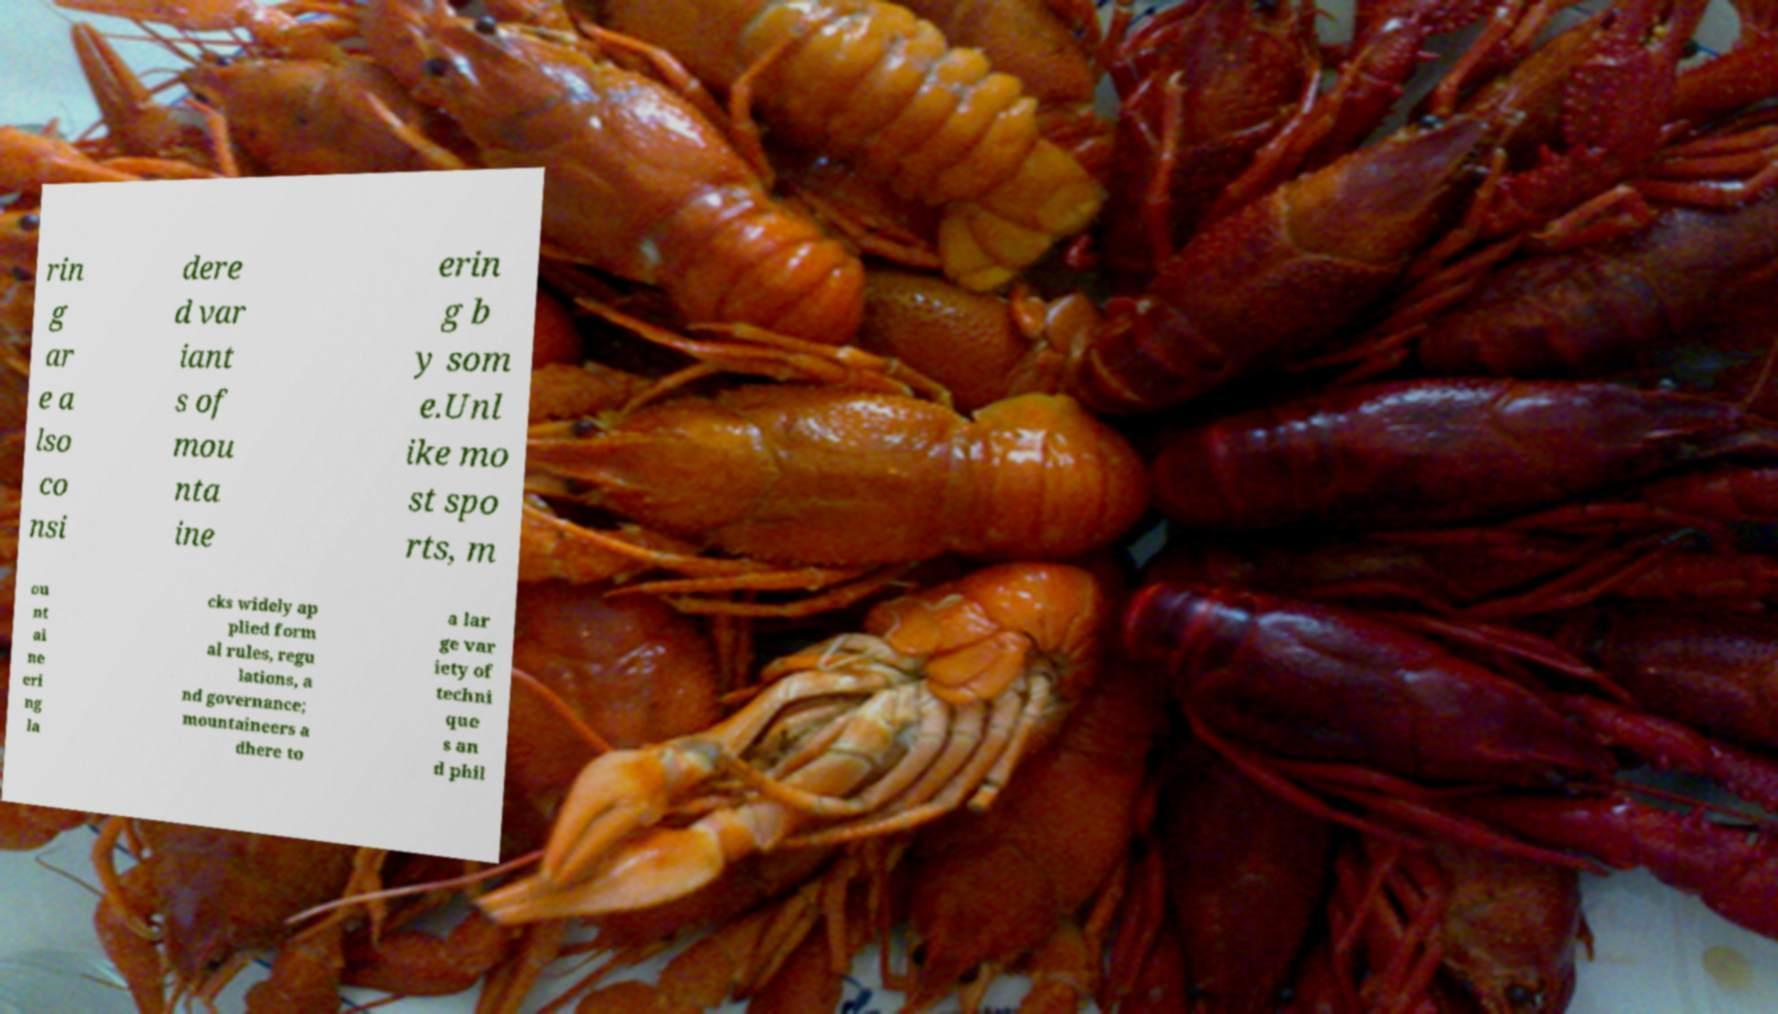For documentation purposes, I need the text within this image transcribed. Could you provide that? rin g ar e a lso co nsi dere d var iant s of mou nta ine erin g b y som e.Unl ike mo st spo rts, m ou nt ai ne eri ng la cks widely ap plied form al rules, regu lations, a nd governance; mountaineers a dhere to a lar ge var iety of techni que s an d phil 